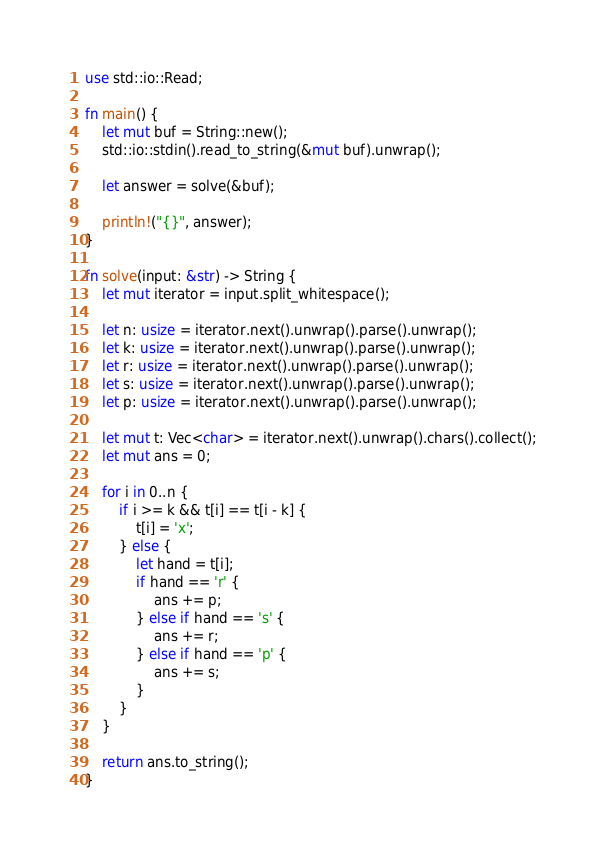Convert code to text. <code><loc_0><loc_0><loc_500><loc_500><_Rust_>use std::io::Read;

fn main() {
    let mut buf = String::new();
    std::io::stdin().read_to_string(&mut buf).unwrap();

    let answer = solve(&buf);

    println!("{}", answer);
}

fn solve(input: &str) -> String {
    let mut iterator = input.split_whitespace();

    let n: usize = iterator.next().unwrap().parse().unwrap();
    let k: usize = iterator.next().unwrap().parse().unwrap();
    let r: usize = iterator.next().unwrap().parse().unwrap();
    let s: usize = iterator.next().unwrap().parse().unwrap();
    let p: usize = iterator.next().unwrap().parse().unwrap();

    let mut t: Vec<char> = iterator.next().unwrap().chars().collect();
    let mut ans = 0;

    for i in 0..n {
        if i >= k && t[i] == t[i - k] {
            t[i] = 'x';
        } else {
            let hand = t[i];
            if hand == 'r' {
                ans += p;
            } else if hand == 's' {
                ans += r;
            } else if hand == 'p' {
                ans += s;
            }
        }
    }

    return ans.to_string();
}
</code> 